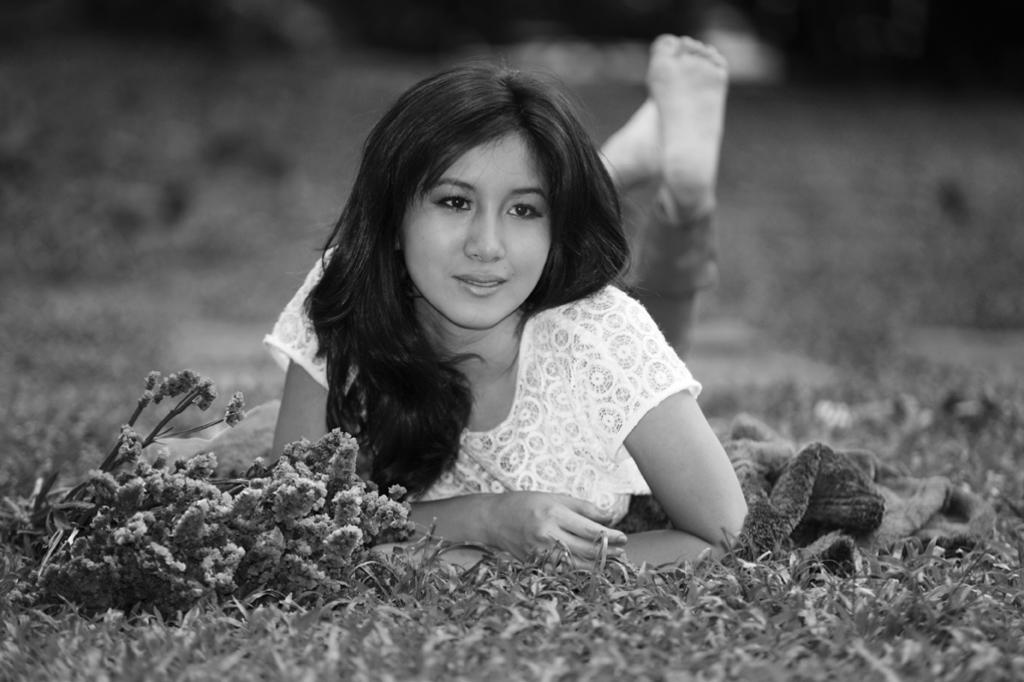What is the color scheme of the image? The image is black and white. Where is the main subject of the image located? There is a girl lying on the grass at the center of the image. What can be seen in front of the girl? There are flowers in front of the girl. What item is placed beside the girl? There is a jacket beside the girl. What angle does the root of the tree make with the ground in the image? There is no tree or root present in the image; it features a girl lying on the grass with flowers and a jacket. 